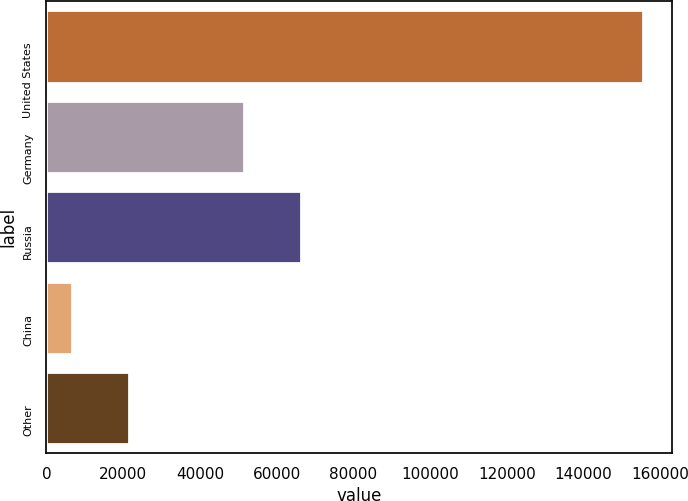Convert chart to OTSL. <chart><loc_0><loc_0><loc_500><loc_500><bar_chart><fcel>United States<fcel>Germany<fcel>Russia<fcel>China<fcel>Other<nl><fcel>155428<fcel>51528<fcel>66412.6<fcel>6582<fcel>21466.6<nl></chart> 